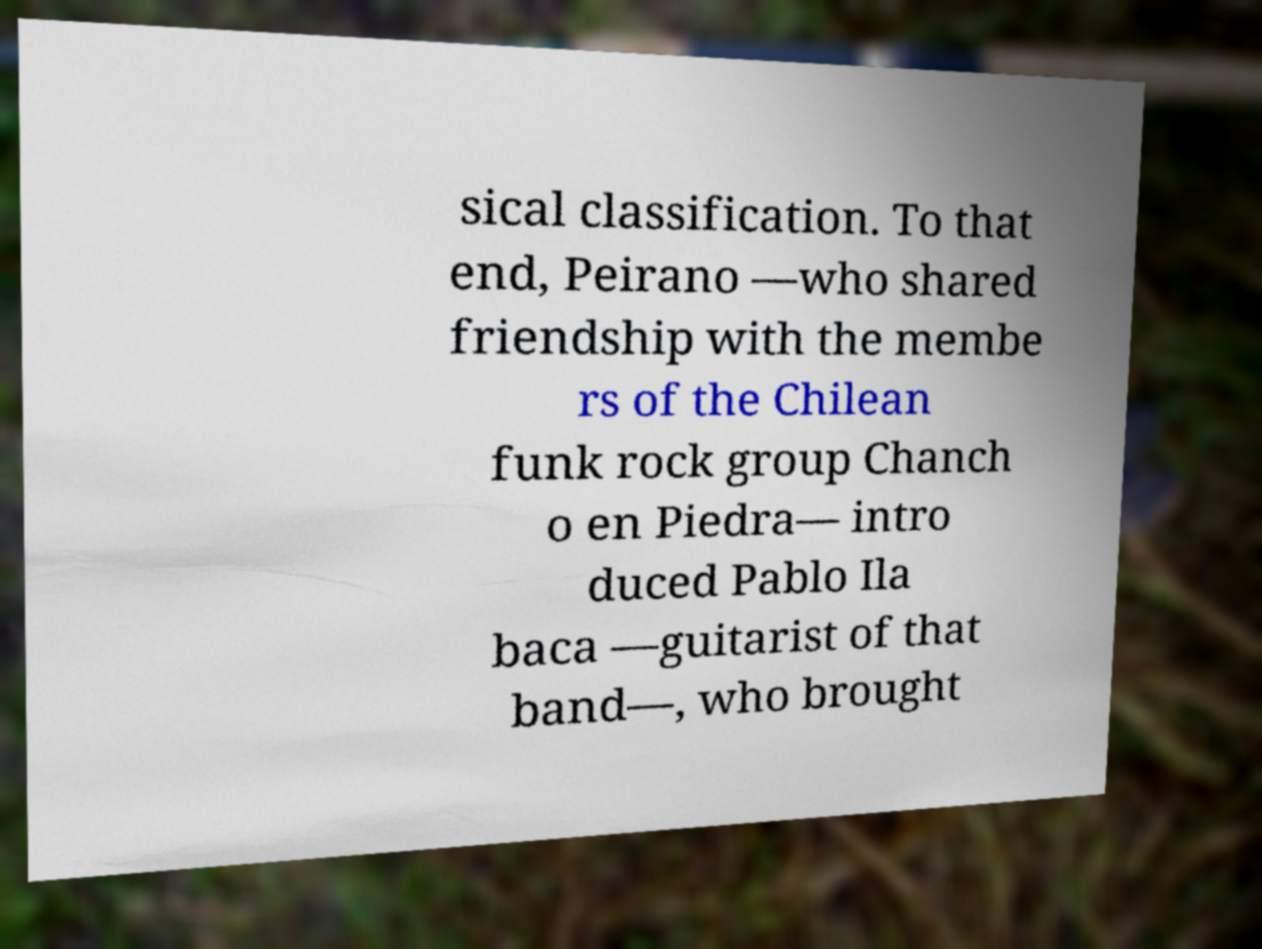Could you extract and type out the text from this image? sical classification. To that end, Peirano —who shared friendship with the membe rs of the Chilean funk rock group Chanch o en Piedra— intro duced Pablo Ila baca —guitarist of that band—, who brought 